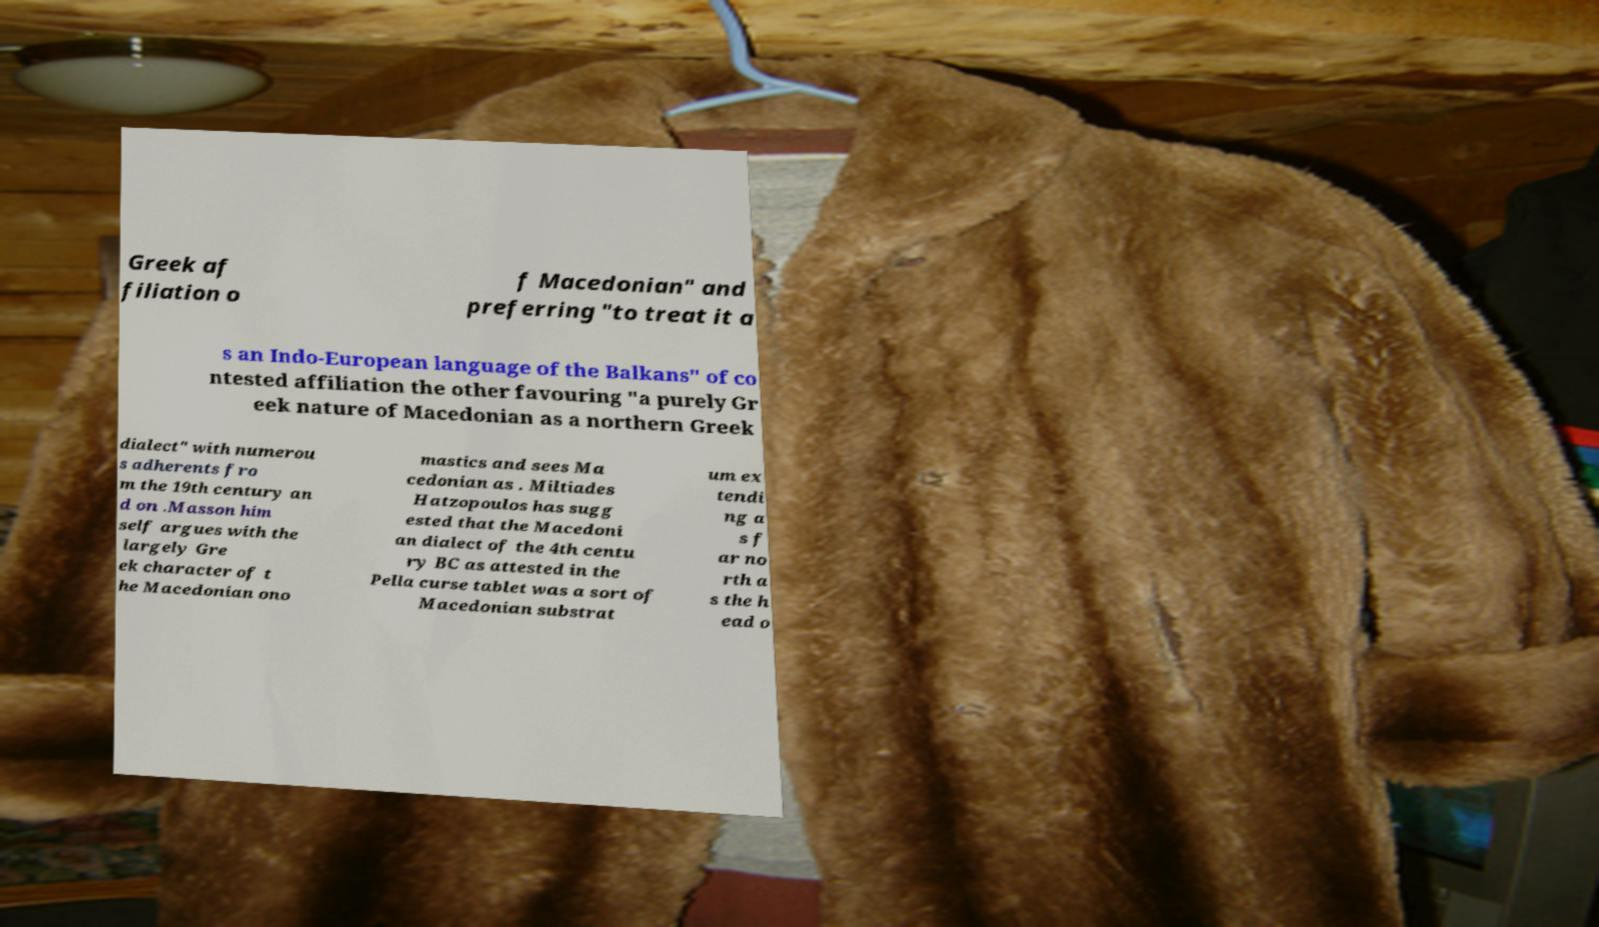Please read and relay the text visible in this image. What does it say? Greek af filiation o f Macedonian" and preferring "to treat it a s an Indo-European language of the Balkans" of co ntested affiliation the other favouring "a purely Gr eek nature of Macedonian as a northern Greek dialect" with numerou s adherents fro m the 19th century an d on .Masson him self argues with the largely Gre ek character of t he Macedonian ono mastics and sees Ma cedonian as . Miltiades Hatzopoulos has sugg ested that the Macedoni an dialect of the 4th centu ry BC as attested in the Pella curse tablet was a sort of Macedonian substrat um ex tendi ng a s f ar no rth a s the h ead o 